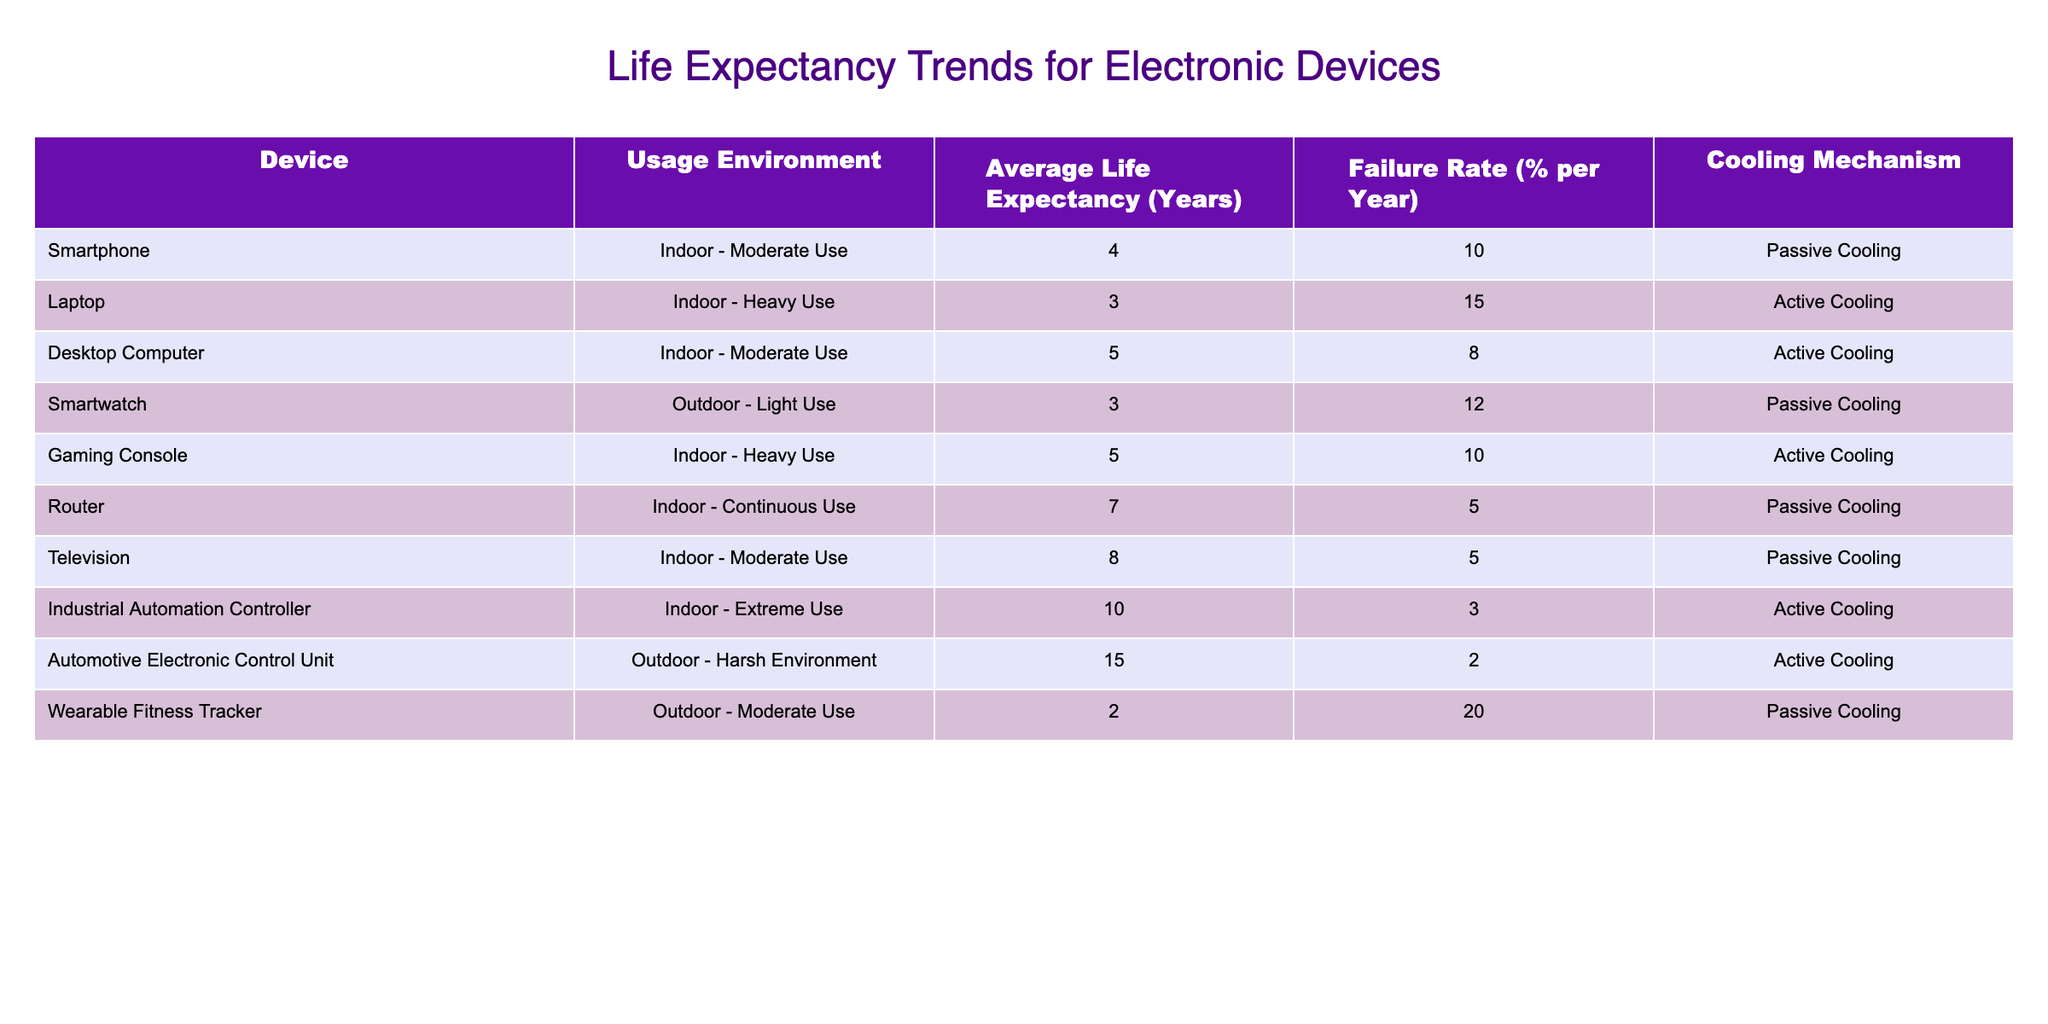What is the average life expectancy of a smartphone? The table lists the average life expectancy of a smartphone as 4 years.
Answer: 4 years Which device has the highest failure rate? The wearable fitness tracker has the highest failure rate at 20% per year.
Answer: 20% What is the life expectancy of a laptop? According to the table, the life expectancy of a laptop is 3 years.
Answer: 3 years How many devices have a life expectancy of 5 years? The devices with a life expectancy of 5 years are the desktop computer and the gaming console. Therefore, there are two devices.
Answer: 2 Is the cooling mechanism for the automotive electronic control unit active? Yes, the automotive electronic control unit has an active cooling mechanism as stated in the table.
Answer: Yes What is the difference in average life expectancy between the router and the smartwatch? The average life expectancy of the router is 7 years and for the smartwatch, it is 3 years. The difference is 7 - 3 = 4 years.
Answer: 4 years If we consider only indoor usage devices, which one has the longest life expectancy? The indoor devices listed are the desktop computer (5 years), gaming console (5 years), router (7 years), and television (8 years). Out of these, the television has the longest life expectancy at 8 years.
Answer: 8 years What is the average life expectancy of devices used in outdoor environments? The outdoor devices are the smartwatch (3 years), automotive electronic control unit (15 years), and wearable fitness tracker (2 years). The average is (3 + 15 + 2) / 3 = 20 / 3 = approximately 6.67 years.
Answer: Approximately 6.67 years Which indoor usage device has the shortest life expectancy? The laptop has the shortest life expectancy of 3 years among indoor usage devices.
Answer: 3 years 